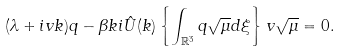<formula> <loc_0><loc_0><loc_500><loc_500>( \lambda + i v k ) q - \beta k i \hat { U } ( k ) \left \{ \int _ { \mathbb { R } ^ { 3 } } q \sqrt { \mu } d \xi \right \} v \sqrt { \mu } = 0 .</formula> 